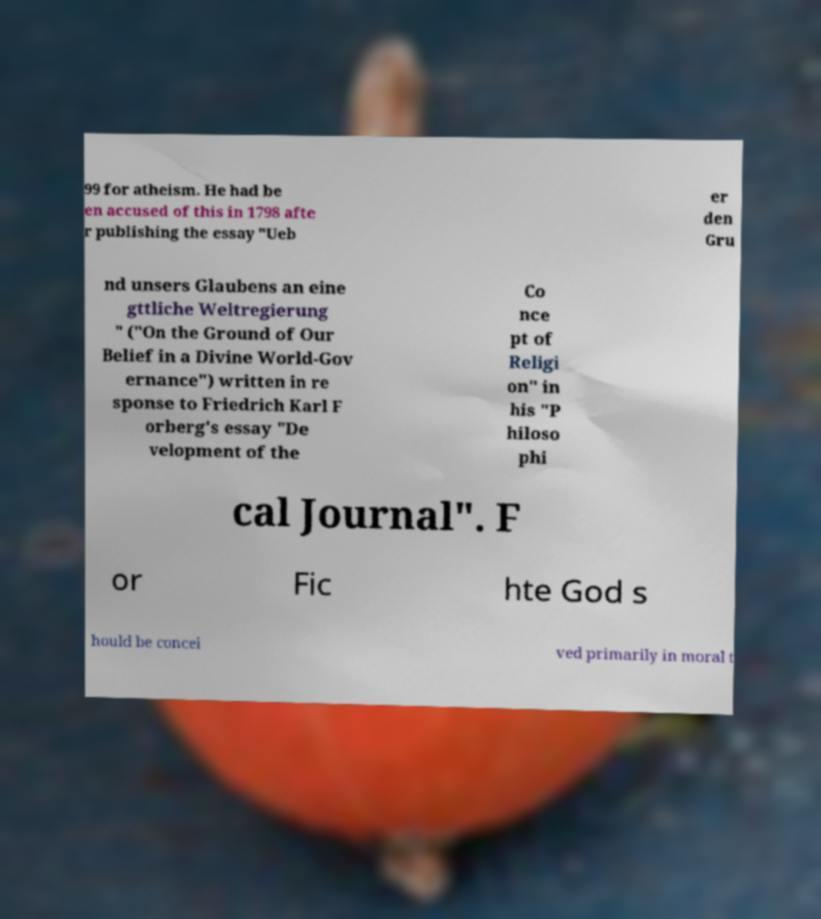Could you extract and type out the text from this image? 99 for atheism. He had be en accused of this in 1798 afte r publishing the essay "Ueb er den Gru nd unsers Glaubens an eine gttliche Weltregierung " ("On the Ground of Our Belief in a Divine World-Gov ernance") written in re sponse to Friedrich Karl F orberg's essay "De velopment of the Co nce pt of Religi on" in his "P hiloso phi cal Journal". F or Fic hte God s hould be concei ved primarily in moral t 